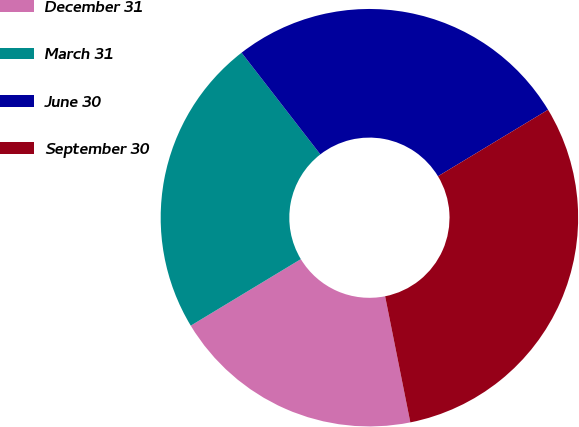<chart> <loc_0><loc_0><loc_500><loc_500><pie_chart><fcel>December 31<fcel>March 31<fcel>June 30<fcel>September 30<nl><fcel>19.49%<fcel>23.16%<fcel>26.84%<fcel>30.51%<nl></chart> 